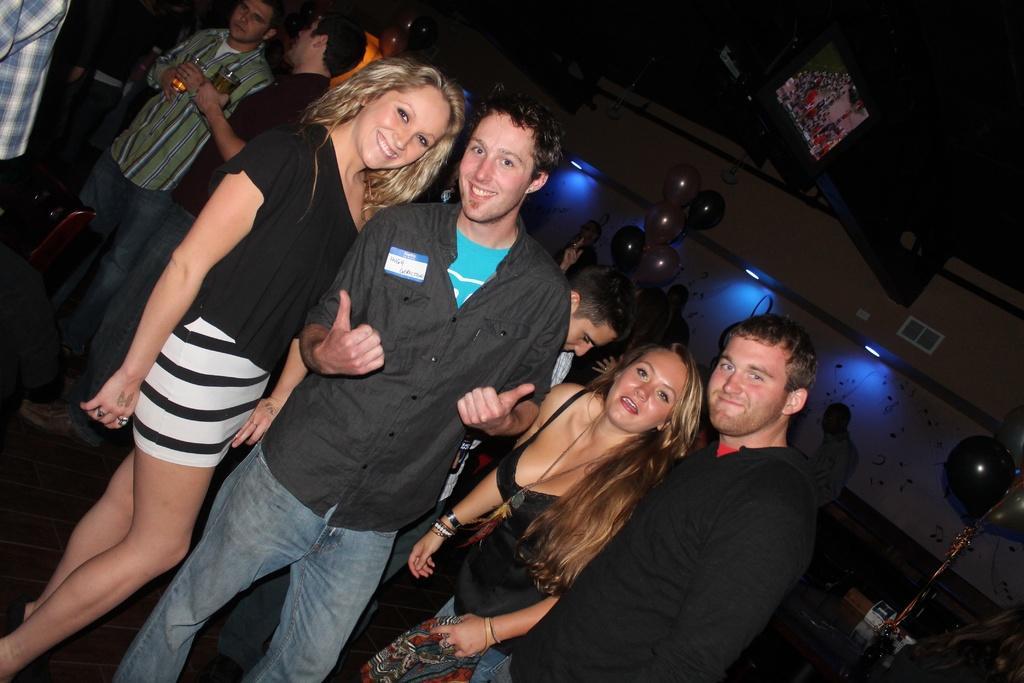In one or two sentences, can you explain what this image depicts? In the center of the image we can see four people are standing and they are smiling and they are in different costumes. In the background there is a wall, lights, few people are standing and a few other objects. 